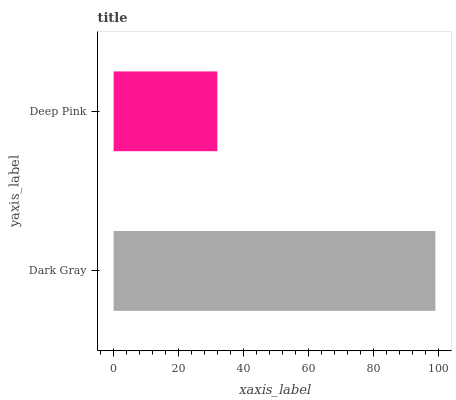Is Deep Pink the minimum?
Answer yes or no. Yes. Is Dark Gray the maximum?
Answer yes or no. Yes. Is Deep Pink the maximum?
Answer yes or no. No. Is Dark Gray greater than Deep Pink?
Answer yes or no. Yes. Is Deep Pink less than Dark Gray?
Answer yes or no. Yes. Is Deep Pink greater than Dark Gray?
Answer yes or no. No. Is Dark Gray less than Deep Pink?
Answer yes or no. No. Is Dark Gray the high median?
Answer yes or no. Yes. Is Deep Pink the low median?
Answer yes or no. Yes. Is Deep Pink the high median?
Answer yes or no. No. Is Dark Gray the low median?
Answer yes or no. No. 